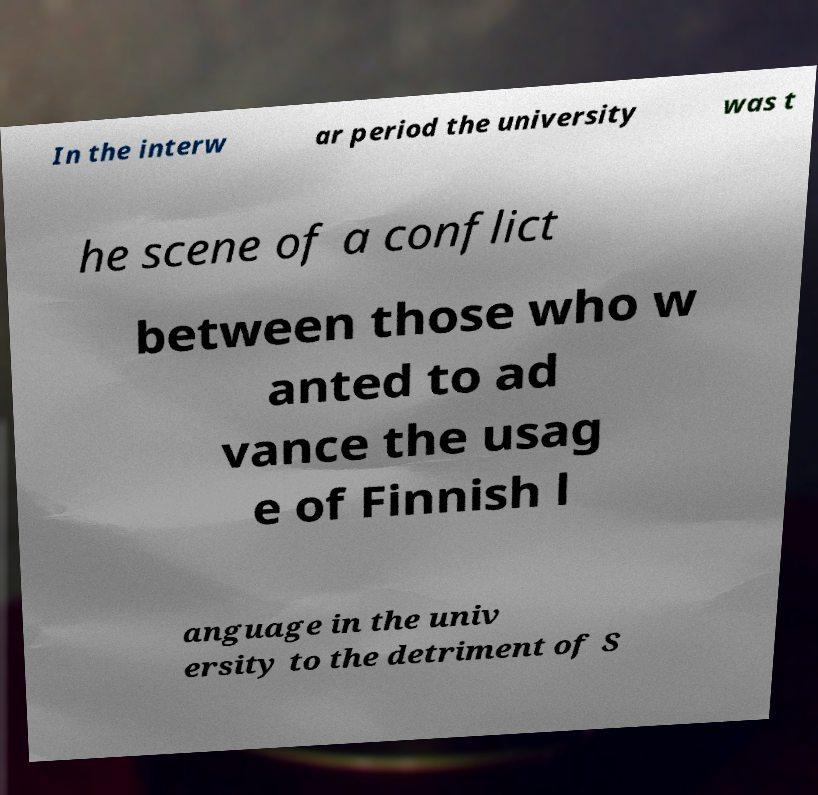There's text embedded in this image that I need extracted. Can you transcribe it verbatim? In the interw ar period the university was t he scene of a conflict between those who w anted to ad vance the usag e of Finnish l anguage in the univ ersity to the detriment of S 